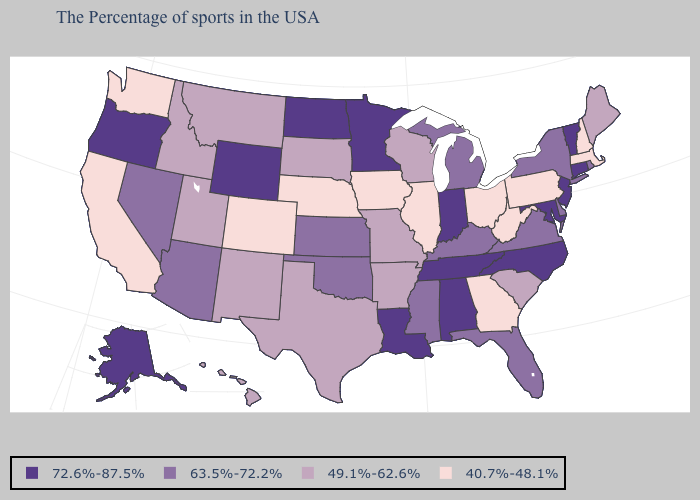Does Massachusetts have the highest value in the USA?
Give a very brief answer. No. Among the states that border Ohio , does Indiana have the highest value?
Write a very short answer. Yes. Name the states that have a value in the range 63.5%-72.2%?
Be succinct. Rhode Island, New York, Delaware, Virginia, Florida, Michigan, Kentucky, Mississippi, Kansas, Oklahoma, Arizona, Nevada. What is the highest value in states that border Kentucky?
Short answer required. 72.6%-87.5%. Name the states that have a value in the range 49.1%-62.6%?
Give a very brief answer. Maine, South Carolina, Wisconsin, Missouri, Arkansas, Texas, South Dakota, New Mexico, Utah, Montana, Idaho, Hawaii. What is the value of Vermont?
Quick response, please. 72.6%-87.5%. Name the states that have a value in the range 72.6%-87.5%?
Short answer required. Vermont, Connecticut, New Jersey, Maryland, North Carolina, Indiana, Alabama, Tennessee, Louisiana, Minnesota, North Dakota, Wyoming, Oregon, Alaska. Does Ohio have the same value as Arkansas?
Concise answer only. No. What is the value of Oklahoma?
Short answer required. 63.5%-72.2%. What is the lowest value in the USA?
Concise answer only. 40.7%-48.1%. Does Missouri have a higher value than New Hampshire?
Answer briefly. Yes. Name the states that have a value in the range 49.1%-62.6%?
Be succinct. Maine, South Carolina, Wisconsin, Missouri, Arkansas, Texas, South Dakota, New Mexico, Utah, Montana, Idaho, Hawaii. What is the value of South Dakota?
Quick response, please. 49.1%-62.6%. What is the value of New Mexico?
Be succinct. 49.1%-62.6%. What is the highest value in states that border Indiana?
Give a very brief answer. 63.5%-72.2%. 